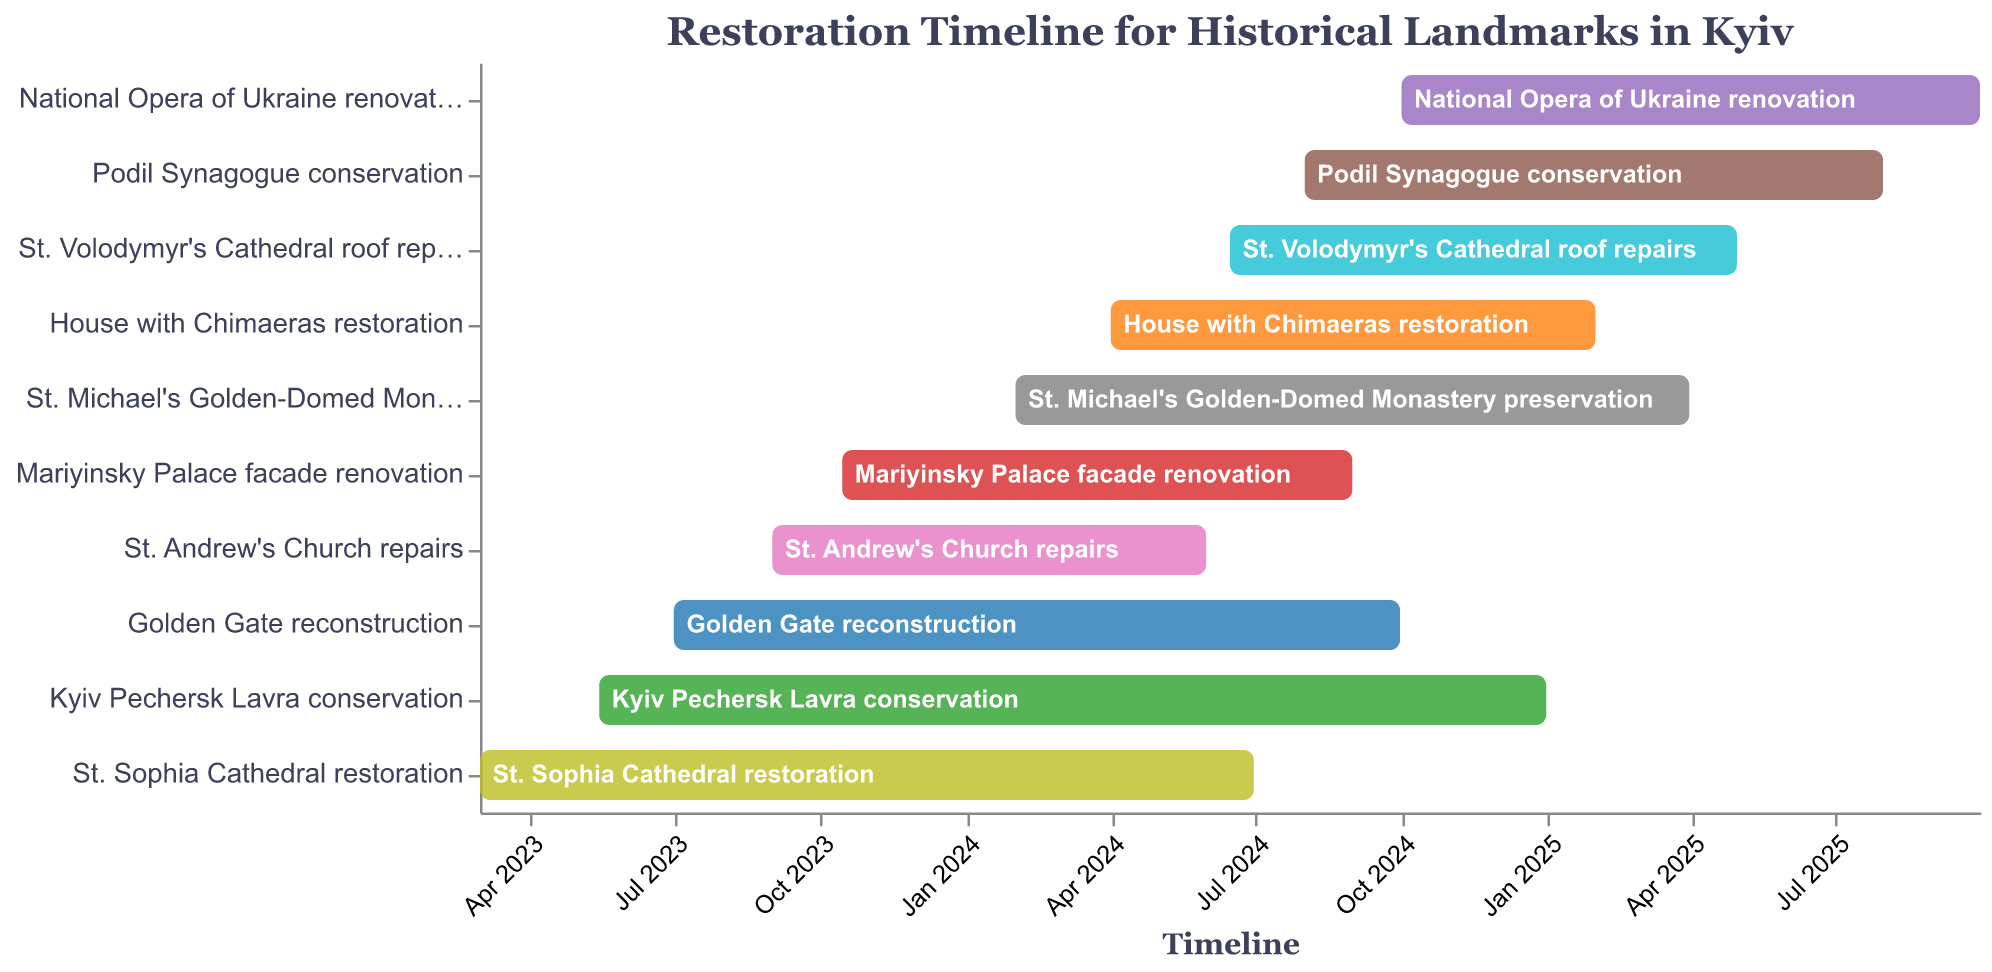What is the title of the chart? The title is displayed at the top of the figure. It reads, "Restoration Timeline for Historical Landmarks in Kyiv."
Answer: Restoration Timeline for Historical Landmarks in Kyiv When does the restoration of St. Sophia Cathedral start and end? The timeline for St. Sophia Cathedral restoration is indicated by the bar length. It starts in March 2023 and ends in June 2024.
Answer: March 2023 to June 2024 Which task has the longest duration? By comparing the lengths of the bars, "Kyiv Pechersk Lavra conservation" has the longest span, from May 2023 to December 2024.
Answer: Kyiv Pechersk Lavra conservation How many tasks are scheduled to start in 2024? Checking the start dates from the chart, there are six tasks starting in 2024: "St. Michael's Golden-Domed Monastery preservation," "House with Chimaeras restoration," "St. Volodymyr's Cathedral roof repairs," "Podil Synagogue conservation," and "National Opera of Ukraine renovation."
Answer: Six tasks Which restoration task ends latest in the timeline? Observing the latest end dates, "National Opera of Ukraine renovation" ends last, in September 2025.
Answer: National Opera of Ukraine renovation What is the duration of the Mariyinsky Palace facade renovation? The start date is October 2023, and the end date is August 2024. Calculating the months between these points results in a 10-month duration.
Answer: 10 months Are there any tasks that overlap completely in their schedule? "St. Volodymyr's Cathedral roof repairs" and "House with Chimaeras restoration" overlap completely from April 2024 to January 2025.
Answer: Yes How many landmarks are undergoing restoration in 2025? By examining the timeline bars extending into 2025, there are five landmarks: "St. Michael's Golden-Domed Monastery preservation," "House with Chimaeras restoration," "St. Volodymyr's Cathedral roof repairs," "Podil Synagogue conservation," and "National Opera of Ukraine renovation."
Answer: Five landmarks Which task has the shortest duration? Comparing the lengths of the bars, "St. Andrew's Church repairs" has the shortest duration, from September 2023 to May 2024, which is 9 months.
Answer: St. Andrew's Church repairs 